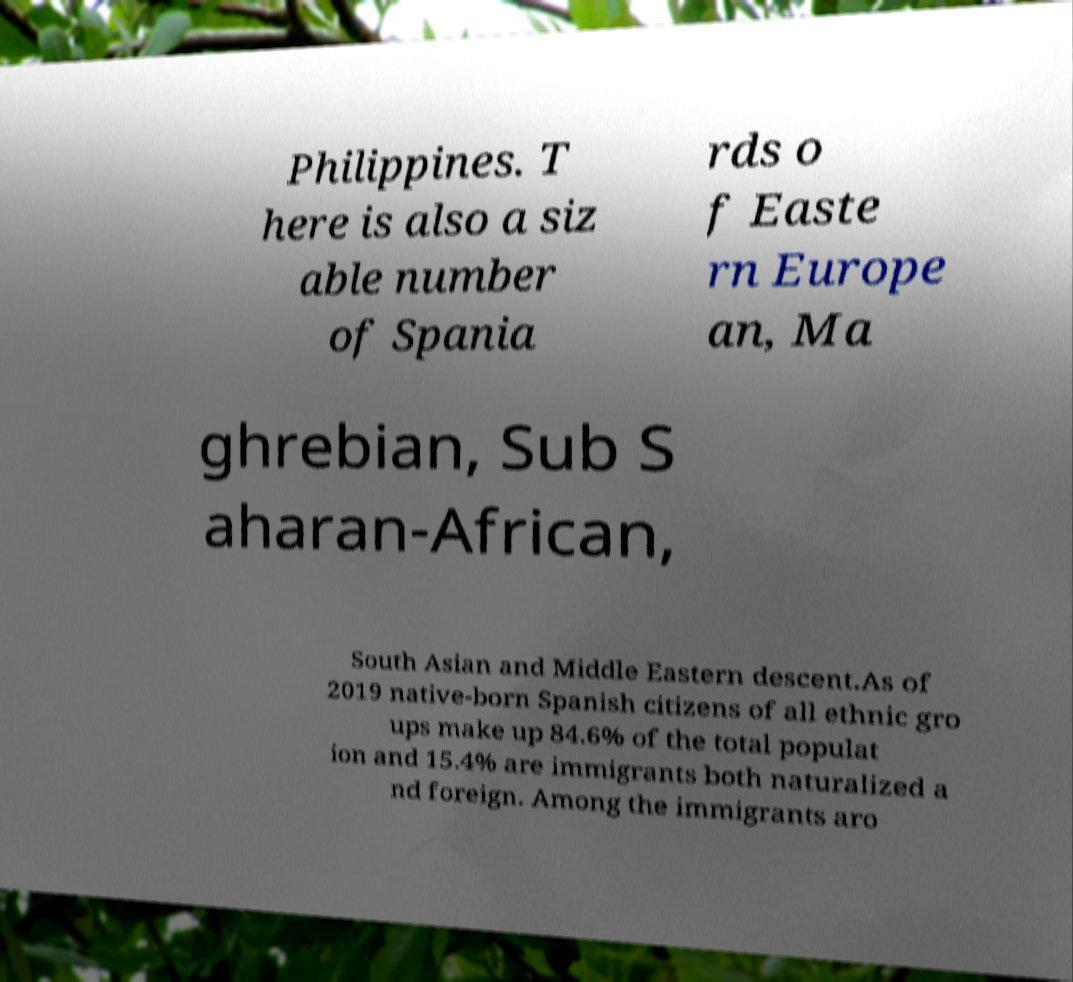There's text embedded in this image that I need extracted. Can you transcribe it verbatim? Philippines. T here is also a siz able number of Spania rds o f Easte rn Europe an, Ma ghrebian, Sub S aharan-African, South Asian and Middle Eastern descent.As of 2019 native-born Spanish citizens of all ethnic gro ups make up 84.6% of the total populat ion and 15.4% are immigrants both naturalized a nd foreign. Among the immigrants aro 